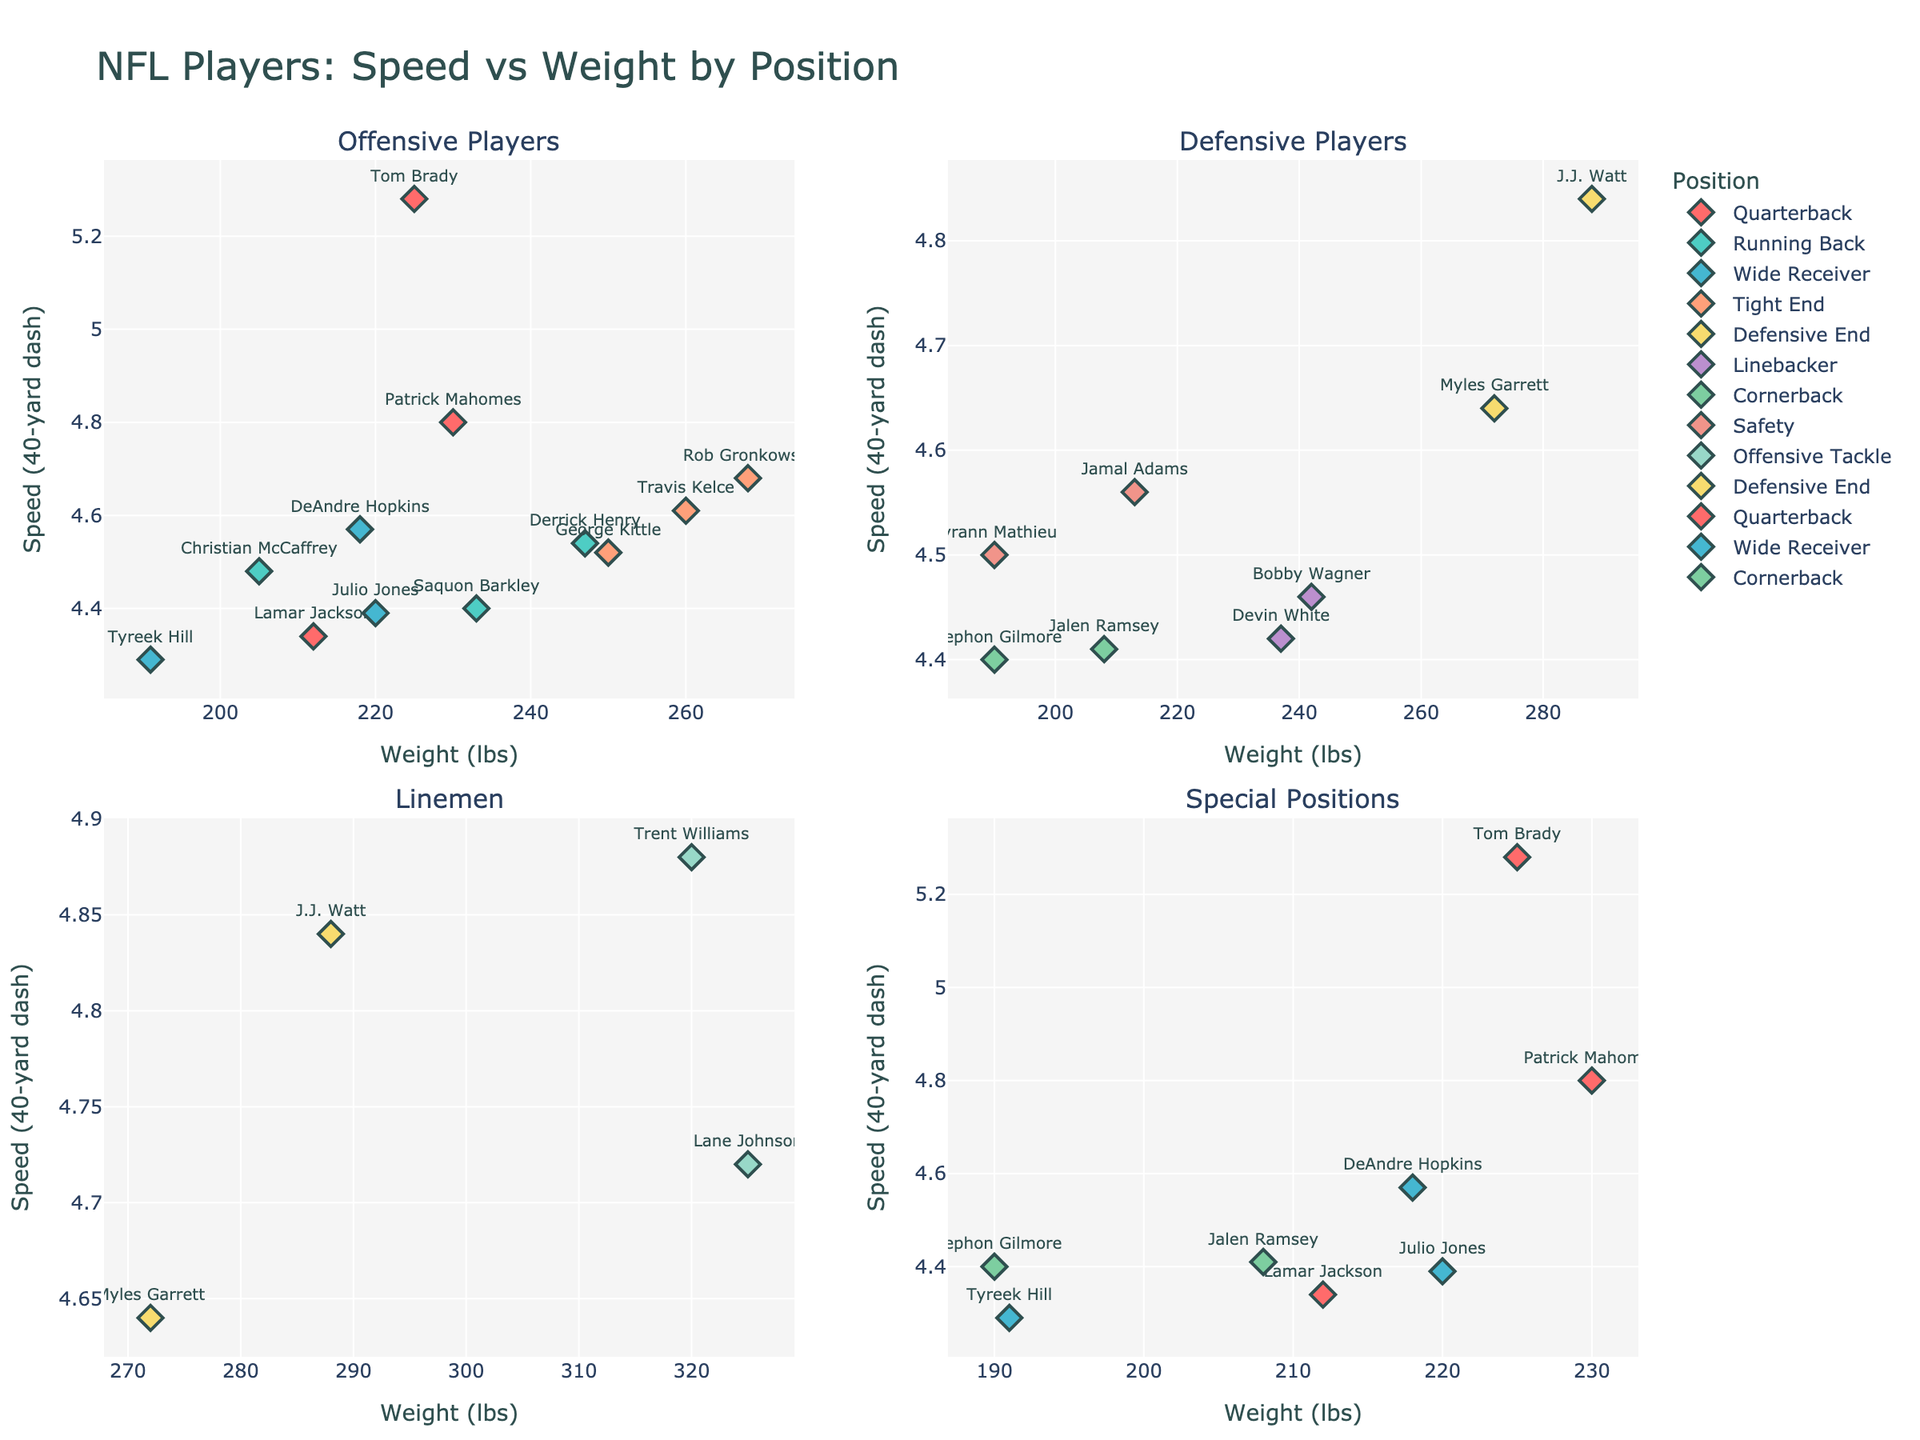Which e-learning platform had the largest market share in 2022? In the pie chart for 2022, identifying the segment with the largest portion indicates Coursera with a market share of 28%.
Answer: Coursera Comparing 2020 and 2022, which platform experienced the most significant increase in market share? Coursera increased from 22% in 2020 to 28% in 2022, a rise of 6%.
Answer: Coursera Which platform's market share decreased the most from 2020 to 2021? Udacity's share dropped from 20% in 2020 to 18% in 2021, a decrease of 2%.
Answer: Udacity What is the total market share of Canvas and Blackboard combined in 2021? Canvas had 9% and Blackboard had 10% in 2021. Combined, they form 9% + 10% = 19%.
Answer: 19% How did the market share of FutureLearn change between 2021 and 2022? FutureLearn's market share decreased from 14% in 2021 to 12% in 2022. The change is 14% - 12% = 2% decrease.
Answer: Decreased by 2% Which platform consistently maintained a market share around 4-5% over the years? The 'Others' category had 4% in 2020 and 2021, and 5% in 2022, indicating a consistent share around this range.
Answer: Others Which two platforms had the smallest market share in 2022? Blackboard and Others both had smaller segments in 2022, at 8% and 5% respectively.
Answer: Blackboard and Others Overall, which year did Coursera see the highest market share and by how much compared to the previous year? In 2022, Coursera had a market share of 28%, the highest, increasing from 25% in 2021, thus a 3% rise.
Answer: 2022 with a 3% increase Comparing edX's market share in 2020 and 2022, what's the difference? edX had a market share of 19% in 2020 and 22% in 2022. The difference is 22% - 19% = 3%.
Answer: 3% 